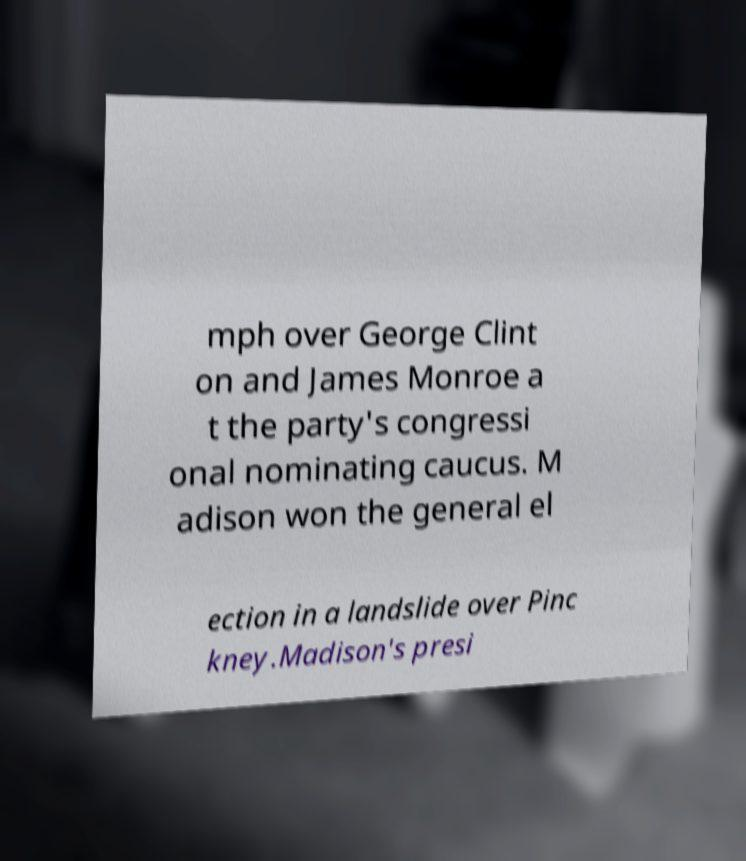Please read and relay the text visible in this image. What does it say? mph over George Clint on and James Monroe a t the party's congressi onal nominating caucus. M adison won the general el ection in a landslide over Pinc kney.Madison's presi 